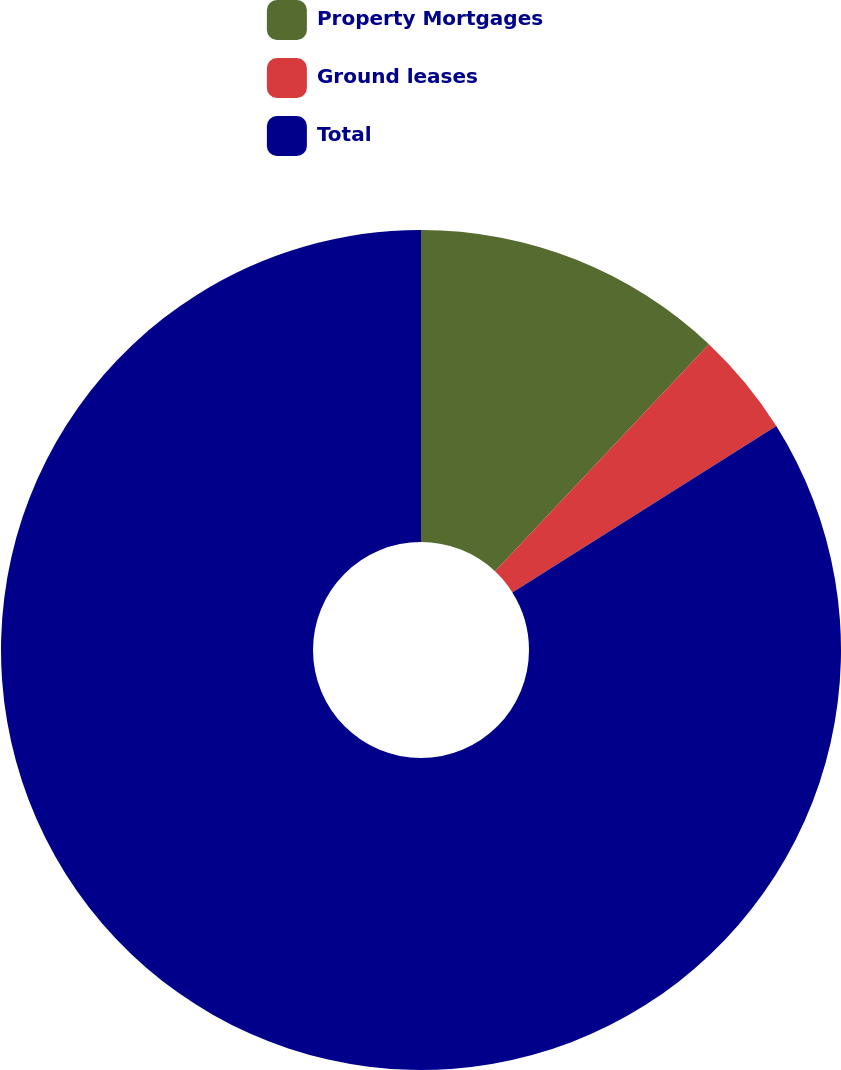<chart> <loc_0><loc_0><loc_500><loc_500><pie_chart><fcel>Property Mortgages<fcel>Ground leases<fcel>Total<nl><fcel>12.02%<fcel>4.03%<fcel>83.94%<nl></chart> 